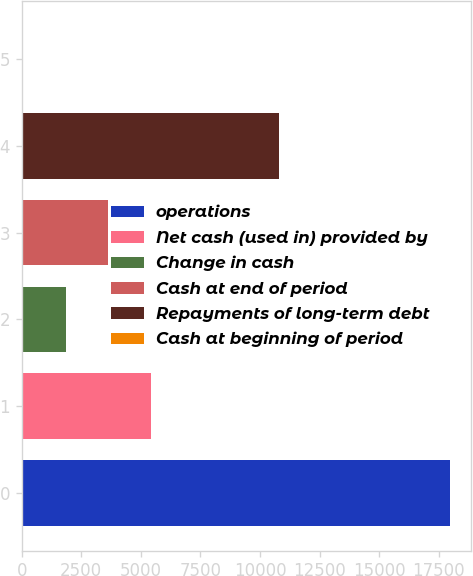Convert chart. <chart><loc_0><loc_0><loc_500><loc_500><bar_chart><fcel>operations<fcel>Net cash (used in) provided by<fcel>Change in cash<fcel>Cash at end of period<fcel>Repayments of long-term debt<fcel>Cash at beginning of period<nl><fcel>17964<fcel>5429.1<fcel>1847.7<fcel>3638.4<fcel>10801.2<fcel>57<nl></chart> 